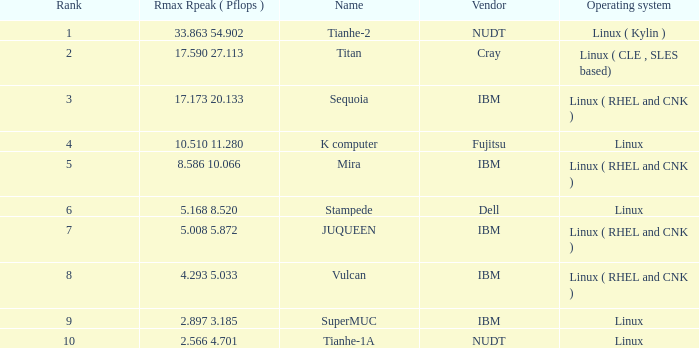What is the rank of Rmax Rpeak ( Pflops ) of 17.173 20.133? 3.0. 